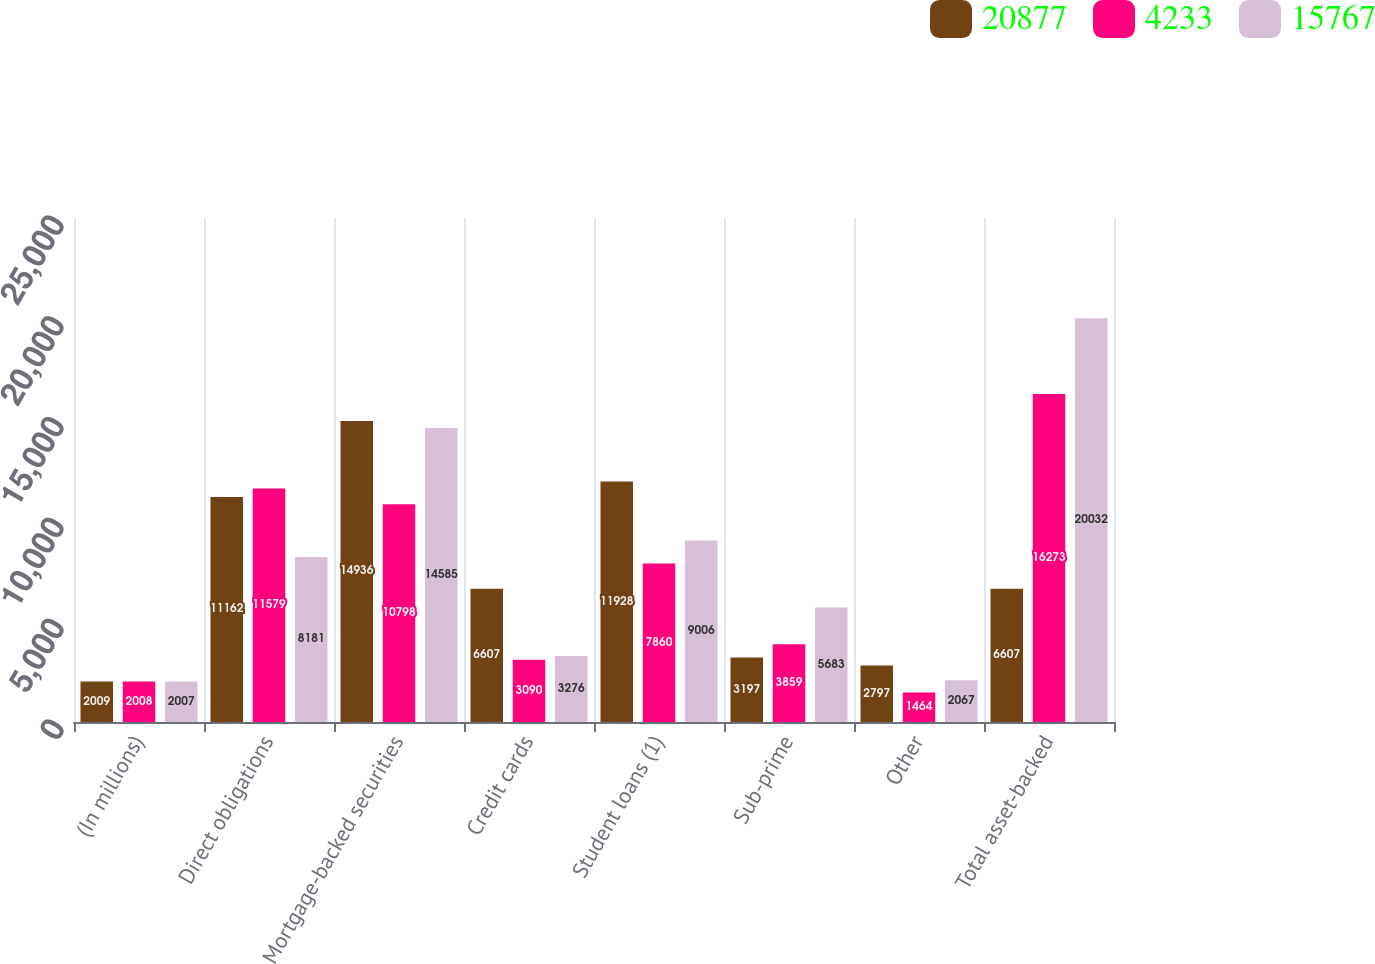Convert chart. <chart><loc_0><loc_0><loc_500><loc_500><stacked_bar_chart><ecel><fcel>(In millions)<fcel>Direct obligations<fcel>Mortgage-backed securities<fcel>Credit cards<fcel>Student loans (1)<fcel>Sub-prime<fcel>Other<fcel>Total asset-backed<nl><fcel>20877<fcel>2009<fcel>11162<fcel>14936<fcel>6607<fcel>11928<fcel>3197<fcel>2797<fcel>6607<nl><fcel>4233<fcel>2008<fcel>11579<fcel>10798<fcel>3090<fcel>7860<fcel>3859<fcel>1464<fcel>16273<nl><fcel>15767<fcel>2007<fcel>8181<fcel>14585<fcel>3276<fcel>9006<fcel>5683<fcel>2067<fcel>20032<nl></chart> 